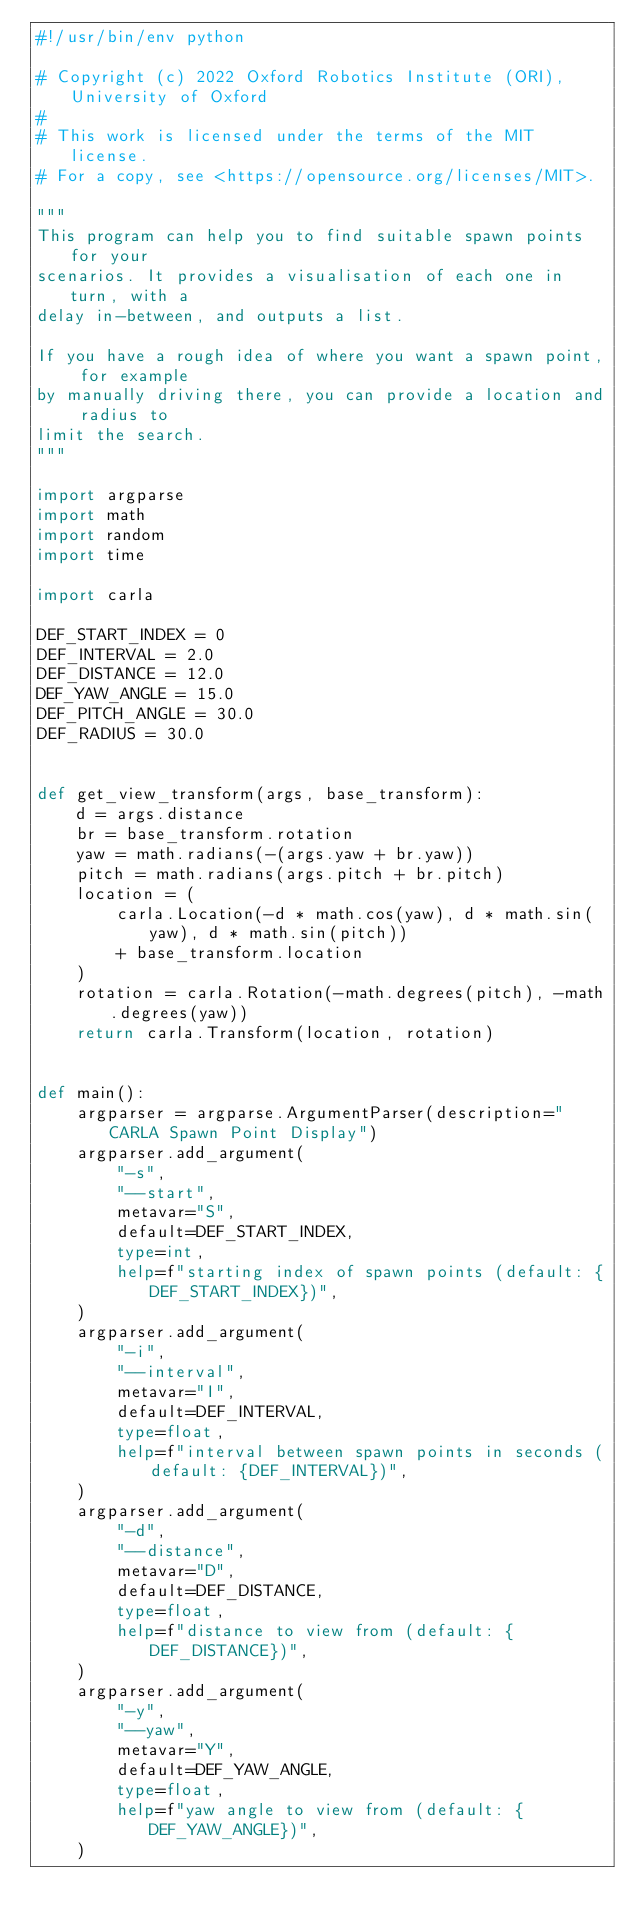Convert code to text. <code><loc_0><loc_0><loc_500><loc_500><_Python_>#!/usr/bin/env python

# Copyright (c) 2022 Oxford Robotics Institute (ORI), University of Oxford
#
# This work is licensed under the terms of the MIT license.
# For a copy, see <https://opensource.org/licenses/MIT>.

"""
This program can help you to find suitable spawn points for your
scenarios. It provides a visualisation of each one in turn, with a
delay in-between, and outputs a list.

If you have a rough idea of where you want a spawn point, for example
by manually driving there, you can provide a location and radius to
limit the search.
"""

import argparse
import math
import random
import time

import carla

DEF_START_INDEX = 0
DEF_INTERVAL = 2.0
DEF_DISTANCE = 12.0
DEF_YAW_ANGLE = 15.0
DEF_PITCH_ANGLE = 30.0
DEF_RADIUS = 30.0


def get_view_transform(args, base_transform):
    d = args.distance
    br = base_transform.rotation
    yaw = math.radians(-(args.yaw + br.yaw))
    pitch = math.radians(args.pitch + br.pitch)
    location = (
        carla.Location(-d * math.cos(yaw), d * math.sin(yaw), d * math.sin(pitch))
        + base_transform.location
    )
    rotation = carla.Rotation(-math.degrees(pitch), -math.degrees(yaw))
    return carla.Transform(location, rotation)


def main():
    argparser = argparse.ArgumentParser(description="CARLA Spawn Point Display")
    argparser.add_argument(
        "-s",
        "--start",
        metavar="S",
        default=DEF_START_INDEX,
        type=int,
        help=f"starting index of spawn points (default: {DEF_START_INDEX})",
    )
    argparser.add_argument(
        "-i",
        "--interval",
        metavar="I",
        default=DEF_INTERVAL,
        type=float,
        help=f"interval between spawn points in seconds (default: {DEF_INTERVAL})",
    )
    argparser.add_argument(
        "-d",
        "--distance",
        metavar="D",
        default=DEF_DISTANCE,
        type=float,
        help=f"distance to view from (default: {DEF_DISTANCE})",
    )
    argparser.add_argument(
        "-y",
        "--yaw",
        metavar="Y",
        default=DEF_YAW_ANGLE,
        type=float,
        help=f"yaw angle to view from (default: {DEF_YAW_ANGLE})",
    )</code> 